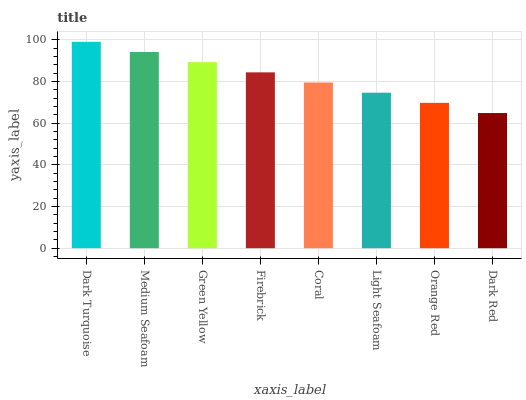Is Dark Red the minimum?
Answer yes or no. Yes. Is Dark Turquoise the maximum?
Answer yes or no. Yes. Is Medium Seafoam the minimum?
Answer yes or no. No. Is Medium Seafoam the maximum?
Answer yes or no. No. Is Dark Turquoise greater than Medium Seafoam?
Answer yes or no. Yes. Is Medium Seafoam less than Dark Turquoise?
Answer yes or no. Yes. Is Medium Seafoam greater than Dark Turquoise?
Answer yes or no. No. Is Dark Turquoise less than Medium Seafoam?
Answer yes or no. No. Is Firebrick the high median?
Answer yes or no. Yes. Is Coral the low median?
Answer yes or no. Yes. Is Light Seafoam the high median?
Answer yes or no. No. Is Green Yellow the low median?
Answer yes or no. No. 